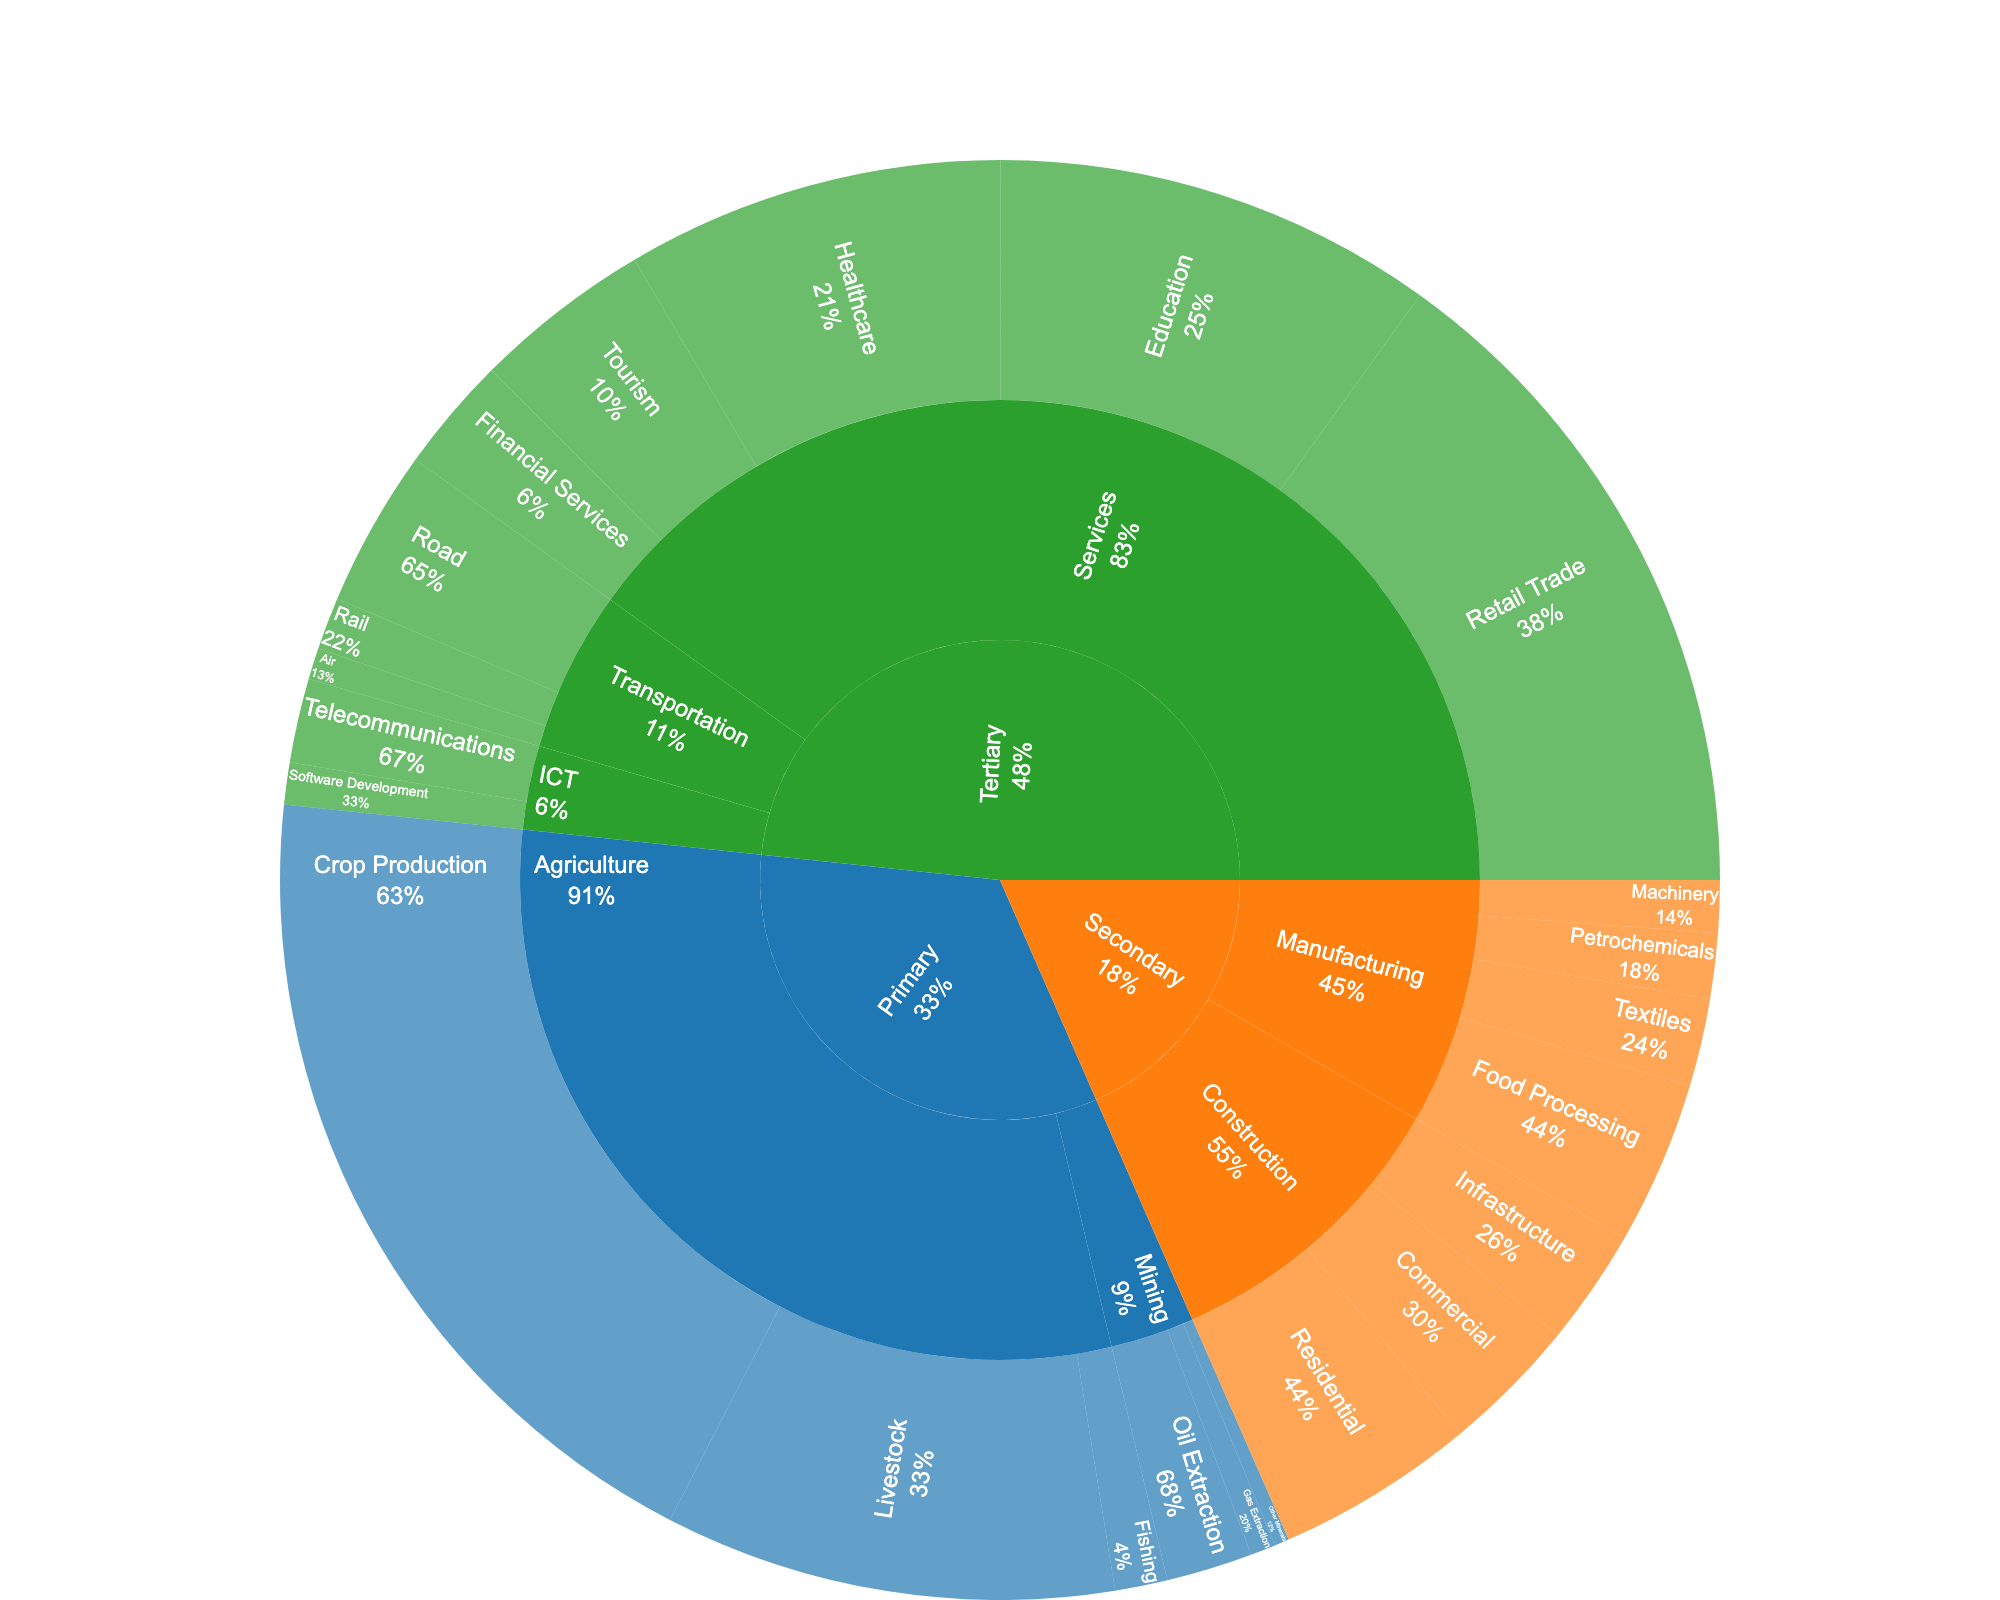what is the title of the figure? The title of the chart is displayed at the top of the sunburst plot. It provides a succinct description of what the chart is depicting.
Answer: Economic Sectors of Azerbaijan by Industry and Employment Which sector has the highest employment? The sunburst plot uses different colors to represent different sectors. The size of each sector's segment correlates with the employment figures. By examining the plot, one can see that the sector with the largest segment has the highest employment.
Answer: Tertiary What is the total employment in the Primary sector? To find the total employment, sum up the employment figures for all sub-industries within the Primary sector. Crop Production (405,000) + Livestock (215,000) + Fishing (25,000) + Oil Extraction (41,000) + Gas Extraction (12,000) + Other Minerals (7,000) = 705,000.
Answer: 705,000 Which sub-industry within the Services industry employs the most people? By drilling down into the Services industry segment of the sunburst plot, one can compare the employment figures for each sub-industry within Services. The sub-industry with the largest segment (in terms of size and percentage) employs the most people.
Answer: Retail Trade How does the employment in the Manufacturing industry compare to that in the Construction industry? Within the Secondary sector, compare the sum of the employment figures in the Manufacturing industry to those in the Construction industry. Manufacturing (78,000 + 42,000 + 31,000 + 25,000) = 176,000 and Construction (95,000 + 65,000 + 55,000) = 215,000.
Answer: Manufacturing has less employment than Construction Are there more employees in Agriculture or ICT? Compare the total employment figures for the Agriculture and ICT industries. Agriculture (405,000 + 215,000 + 25,000) = 645,000; ICT (40,000 + 20,000) = 60,000.
Answer: Agriculture What percentage of employment in the Tertiary sector is from the Retail Trade sub-industry? First, determine the total employment in the Tertiary sector by summing all its sub-industries. Then, calculate the percentage by dividing the Retail Trade employment by the Tertiary sector total and multiplying by 100. Tertiary total (320,000 + 85,000 + 55,000 + 210,000 + 180,000 + 75,000 + 25,000 + 15,000 + 40,000 + 20,000) = 1,025,000; (320,000 / 1,025,000) * 100 ≈ 31.2%.
Answer: Approximately 31.2% What is the least represented sub-industry in terms of employment within the Primary sector? In the Primary sector, compare the employment figures for each sub-industry. The sub-industry with the smallest segment and number is the least represented in terms of employment.
Answer: Other Minerals Which sector has a more diverse distribution of employment across its industries: Primary or Tertiary? By examining the sunburst plot, diversity in employment distribution is indicated by similar segment sizes across different industries within a sector. The Primary sector shows large differences in sub-industry employment, whereas the Tertiary sector segments are more evenly distributed in size.
Answer: Tertiary What is the employment difference between the largest and smallest sub-industries in the Secondary sector? Identify the largest (Residential Construction with 95,000) and smallest (Machinery with 25,000) sub-industries in the Secondary sector and subtract the smallest employment figure from the largest. 95,000 - 25,000 = 70,000.
Answer: 70,000 